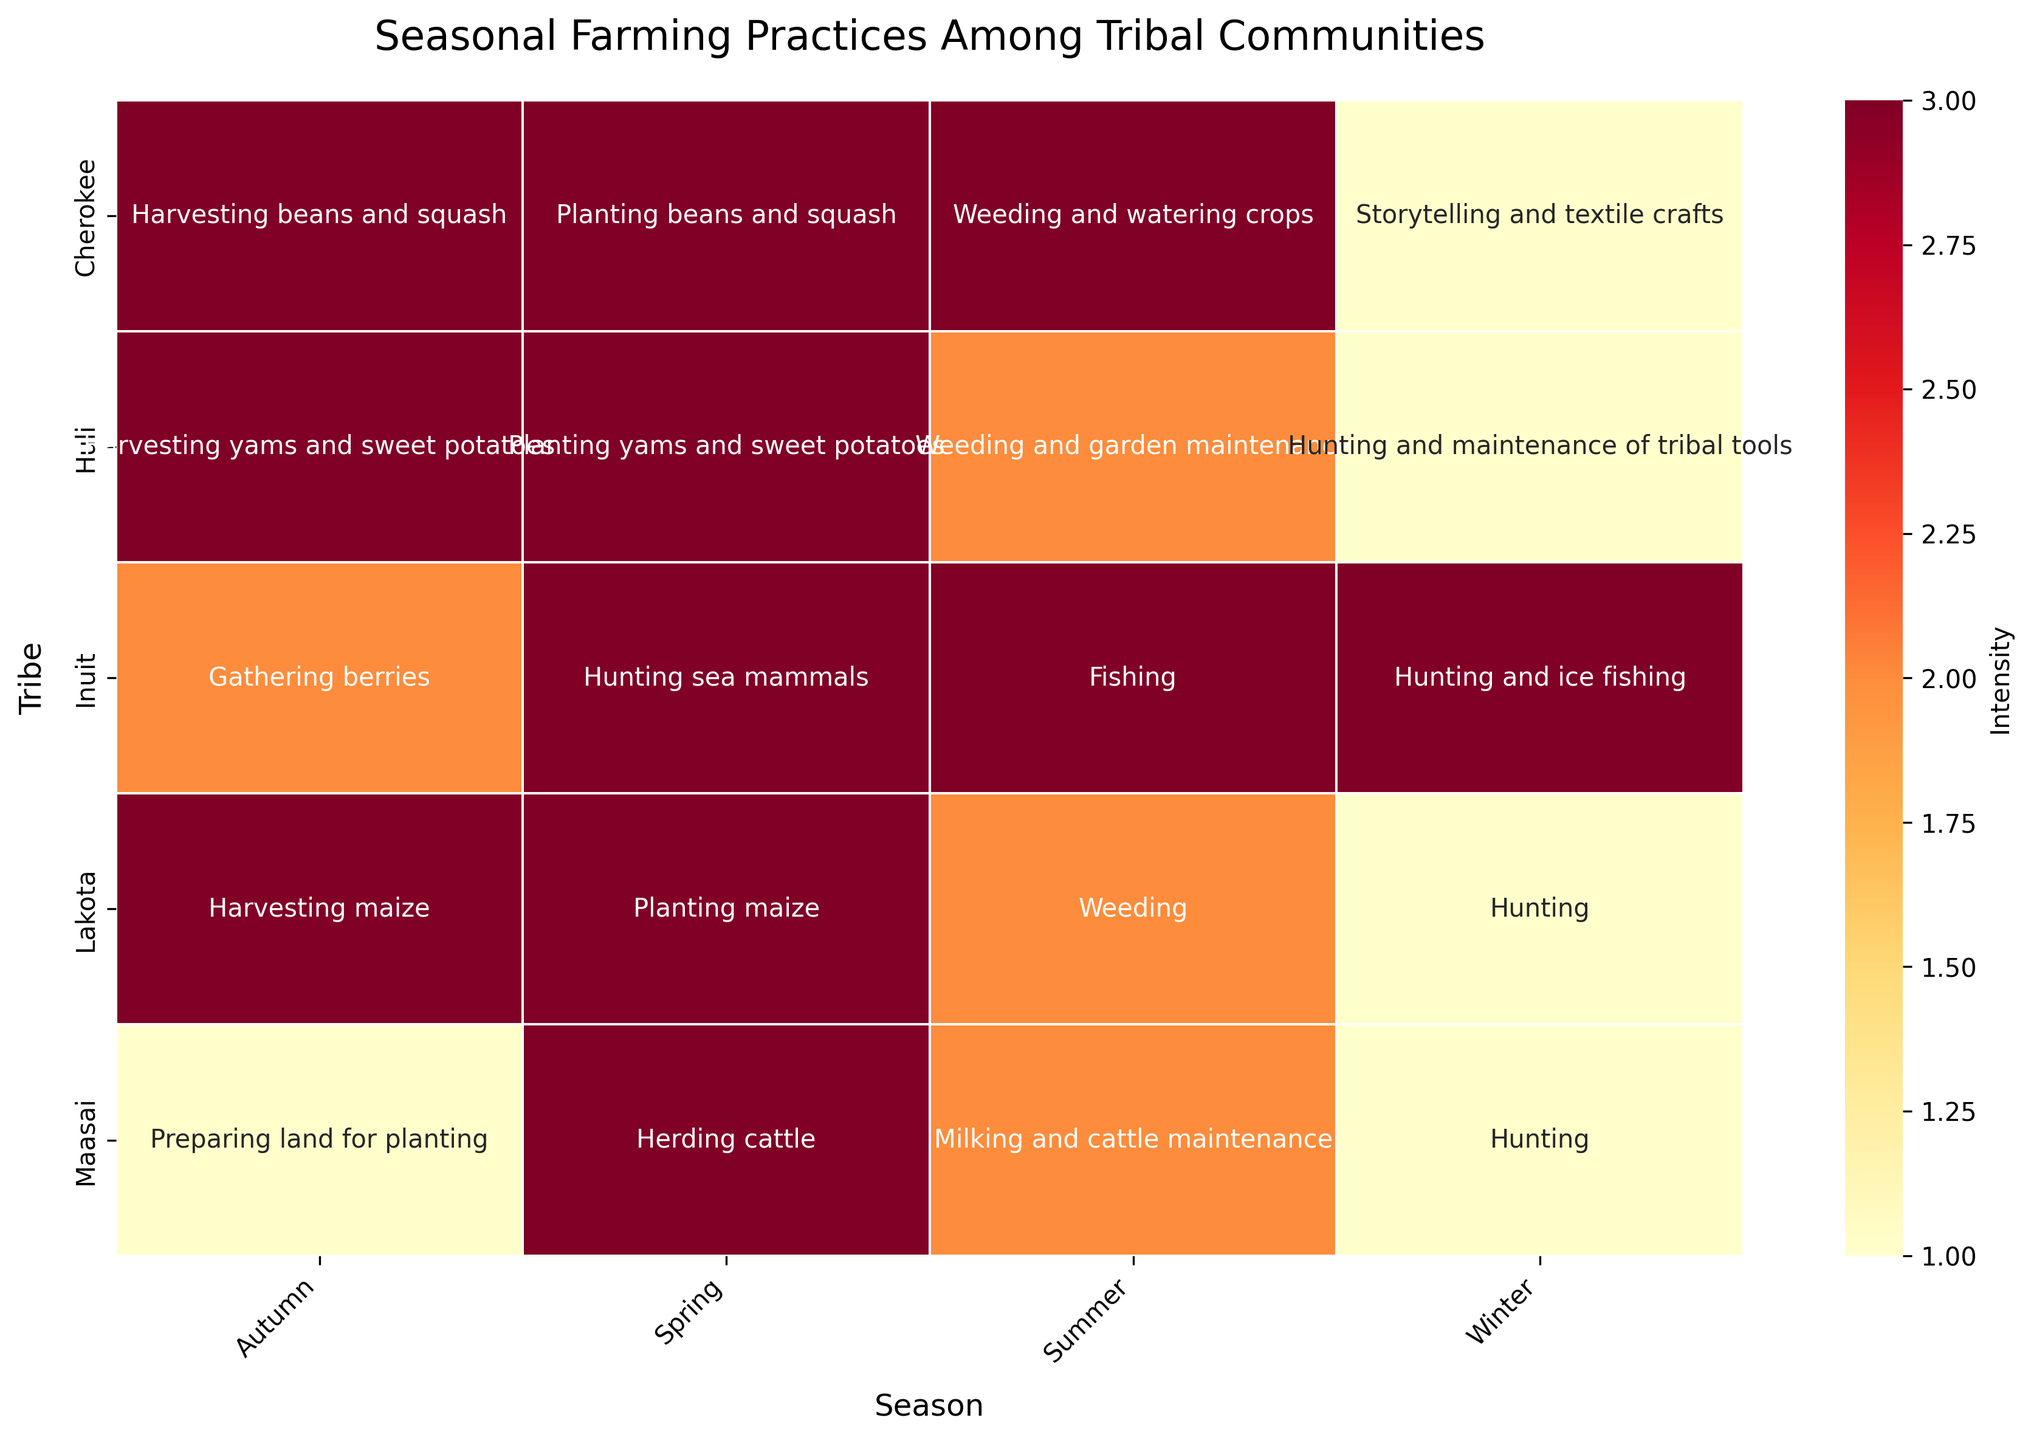Which tribe has high intensity in all four seasons? To find this, locate the tribe rows whose heatmap cells for all seasons (spring, summer, autumn, winter) are colored with the highest intensity (darkest color). The Cherokee tribe has high intensity in all four seasons.
Answer: Cherokee What activity does the Maasai tribe perform in summer? Check the cell corresponding to the Maasai tribe and the summer column and read the activity labeled within the heatmap’s cell. The activity shown is "Milking and cattle maintenance".
Answer: Milking and cattle maintenance Which season shows the highest intensity for the Inuit tribe? For the Inuit tribe row, identify the season columns (spring, summer, autumn, winter) and find the one with the highest intensity (darkest color). This shows that both spring, summer, and winter have high intensity.
Answer: Spring, Summer, Winter Do any tribes have a low-intensity activity in autumn? Examine the autumn column in the heatmap and look for cells with the lowest intensity (lightest color). The Maasai tribe has a low-intensity activity in this season.
Answer: Maasai What seasonal activity do the Huli tribe and the Lakota tribe both perform in winter? Observe the winter column and find the activities labeled in the cells for both the Huli tribe and the Lakota tribe. Both tribes perform hunting, as the activities are "Hunting and maintenance of tribal tools" for the Huli and "Hunting" for the Lakota.
Answer: Hunting How does the planting activity in spring compare between the tribes? Look at the cells under the spring column for each tribe and compare the intensity shades for planting-related activities. Both the Lakota ("Planting maize"), Cherokee ("Planting beans and squash"), and Huli ("Planting yams and sweet potatoes") have high intensity.
Answer: High Which season features the most high-intensity activities across all tribes? For each season column, count the number of times the highest intensity color appears and determine the season with the most high-intensity activities. Both spring and autumn have high intensity in multiple tribes.
Answer: Spring and Autumn Which activity is conducted by the Lakota tribe in spring? Check the cell for the Lakota tribe under the spring column to find the activity noted in that cell. The activity shown is "Planting maize".
Answer: Planting maize What intensity level does the Cherokee tribe have during storytelling and textile crafts in winter? Find the Cherokee tribe row and the winter column to locate the noted intensity level associated with "Storytelling and textile crafts". The intensity level is low (lightest color).
Answer: Low 